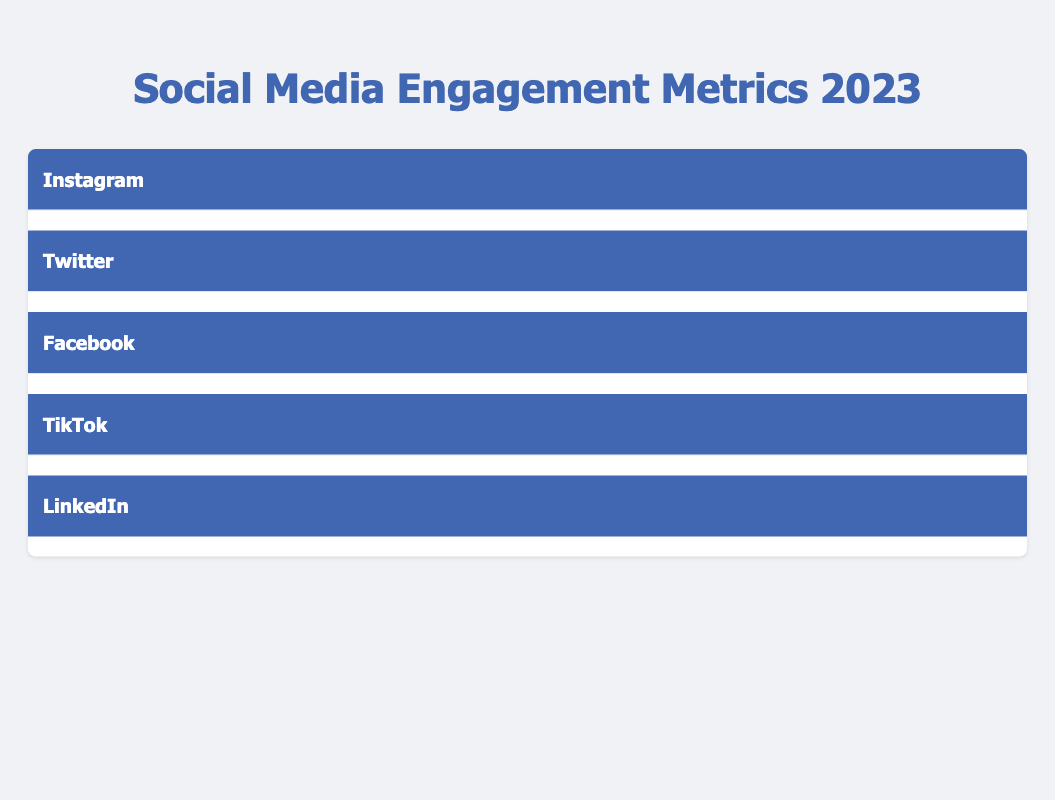What is the Average Likes Per Post on Instagram? The table shows that for Instagram, the metric for Average Likes Per Post is listed directly as 350, so this is the value to provide.
Answer: 350 What is the Follower Growth Rate for TikTok? According to the table, TikTok's Follower Growth Rate is indicated as 10% per month. This requires simply locating the metric under TikTok's section.
Answer: 10% per month Which platform has the highest Average Likes Per Video? The table displays that TikTok has an Average Likes Per Video of 500, which is higher than the likes per post on other platforms. Therefore, TikTok has the highest value in this category.
Answer: TikTok What is the sum of Average Comments Per Post for Facebook and LinkedIn? For Facebook, the Average Comments Per Post is 35, and for LinkedIn, it is 20. Adding these two values gives 35 + 20 = 55. This becomes the answer.
Answer: 55 Is the Hashtag Engagement Rate for Twitter greater than the Stories Engagement Rate for Instagram? The Hashtag Engagement Rate for Twitter is 40%, while the Stories Engagement Rate for Instagram is 30%. Comparing these two values shows that 40% is indeed greater than 30%, confirming the statement as true.
Answer: Yes What is the difference in Follower Growth Rate between TikTok and LinkedIn? TikTok has a Follower Growth Rate of 10% per month while LinkedIn has 2% per month. Calculating the difference gives 10 - 2 = 8%. This result offers the answer.
Answer: 8% What is the average number of shares per post for Facebook and LinkedIn combined? For Facebook, Shares Per Post is 25 and for LinkedIn, it is 10. The average is calculated as (25 + 10) / 2 = 17.5. This value is rounded down for a concise answer.
Answer: 17 Which platform has a higher Engagement Rate: Stories Engagement Rate for Instagram or Content Engagement Rate for LinkedIn? Instagram has a Stories Engagement Rate of 30% and LinkedIn has a Content Engagement Rate of 25%. Comparing both shows that 30% is greater than 25%, thus making Instagram the higher of the two.
Answer: Instagram What is the total number of average reactions per post across all platforms? The Average Reactions Per Post is 150 for Facebook and there are no reaction metrics listed for the other platforms. Therefore, the total is simply 150 as this is the only data point relevant for reactions.
Answer: 150 